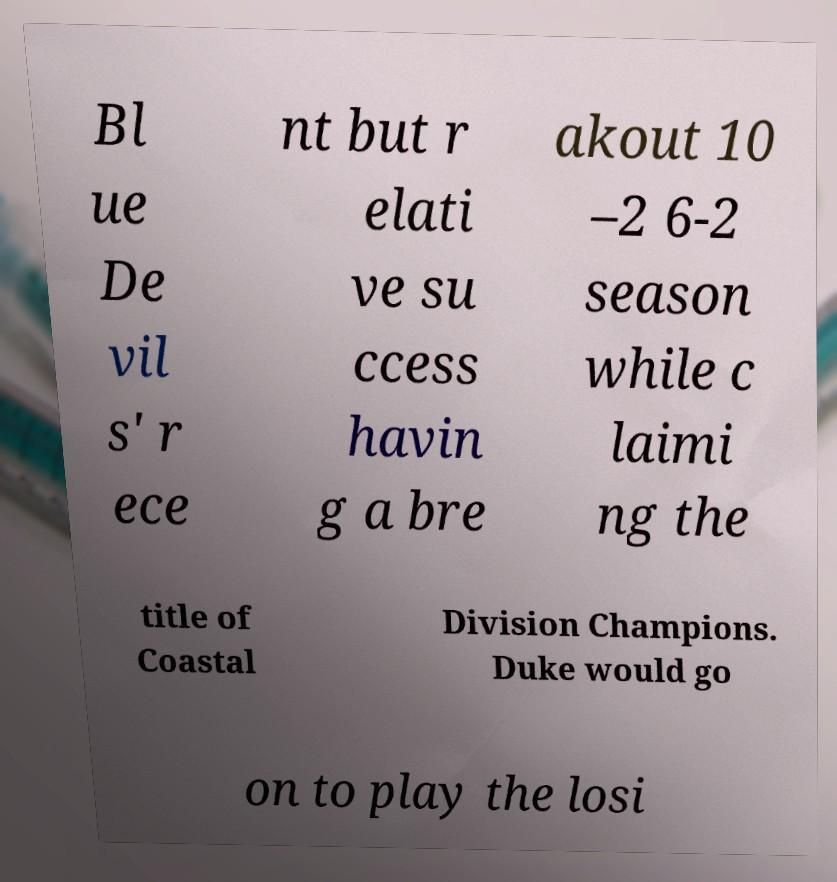Can you read and provide the text displayed in the image?This photo seems to have some interesting text. Can you extract and type it out for me? Bl ue De vil s' r ece nt but r elati ve su ccess havin g a bre akout 10 –2 6-2 season while c laimi ng the title of Coastal Division Champions. Duke would go on to play the losi 